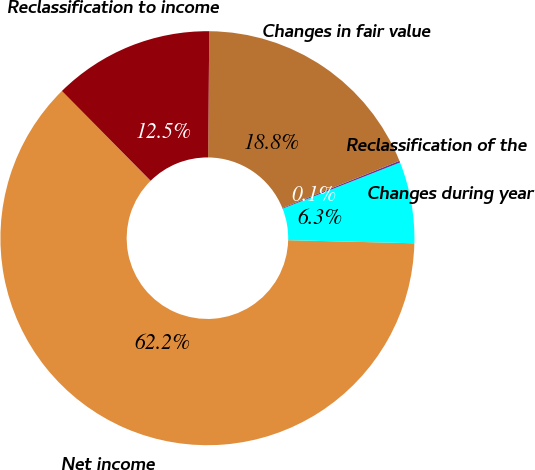<chart> <loc_0><loc_0><loc_500><loc_500><pie_chart><fcel>Net income<fcel>Changes during year<fcel>Reclassification of the<fcel>Changes in fair value<fcel>Reclassification to income<nl><fcel>62.2%<fcel>6.35%<fcel>0.14%<fcel>18.76%<fcel>12.55%<nl></chart> 